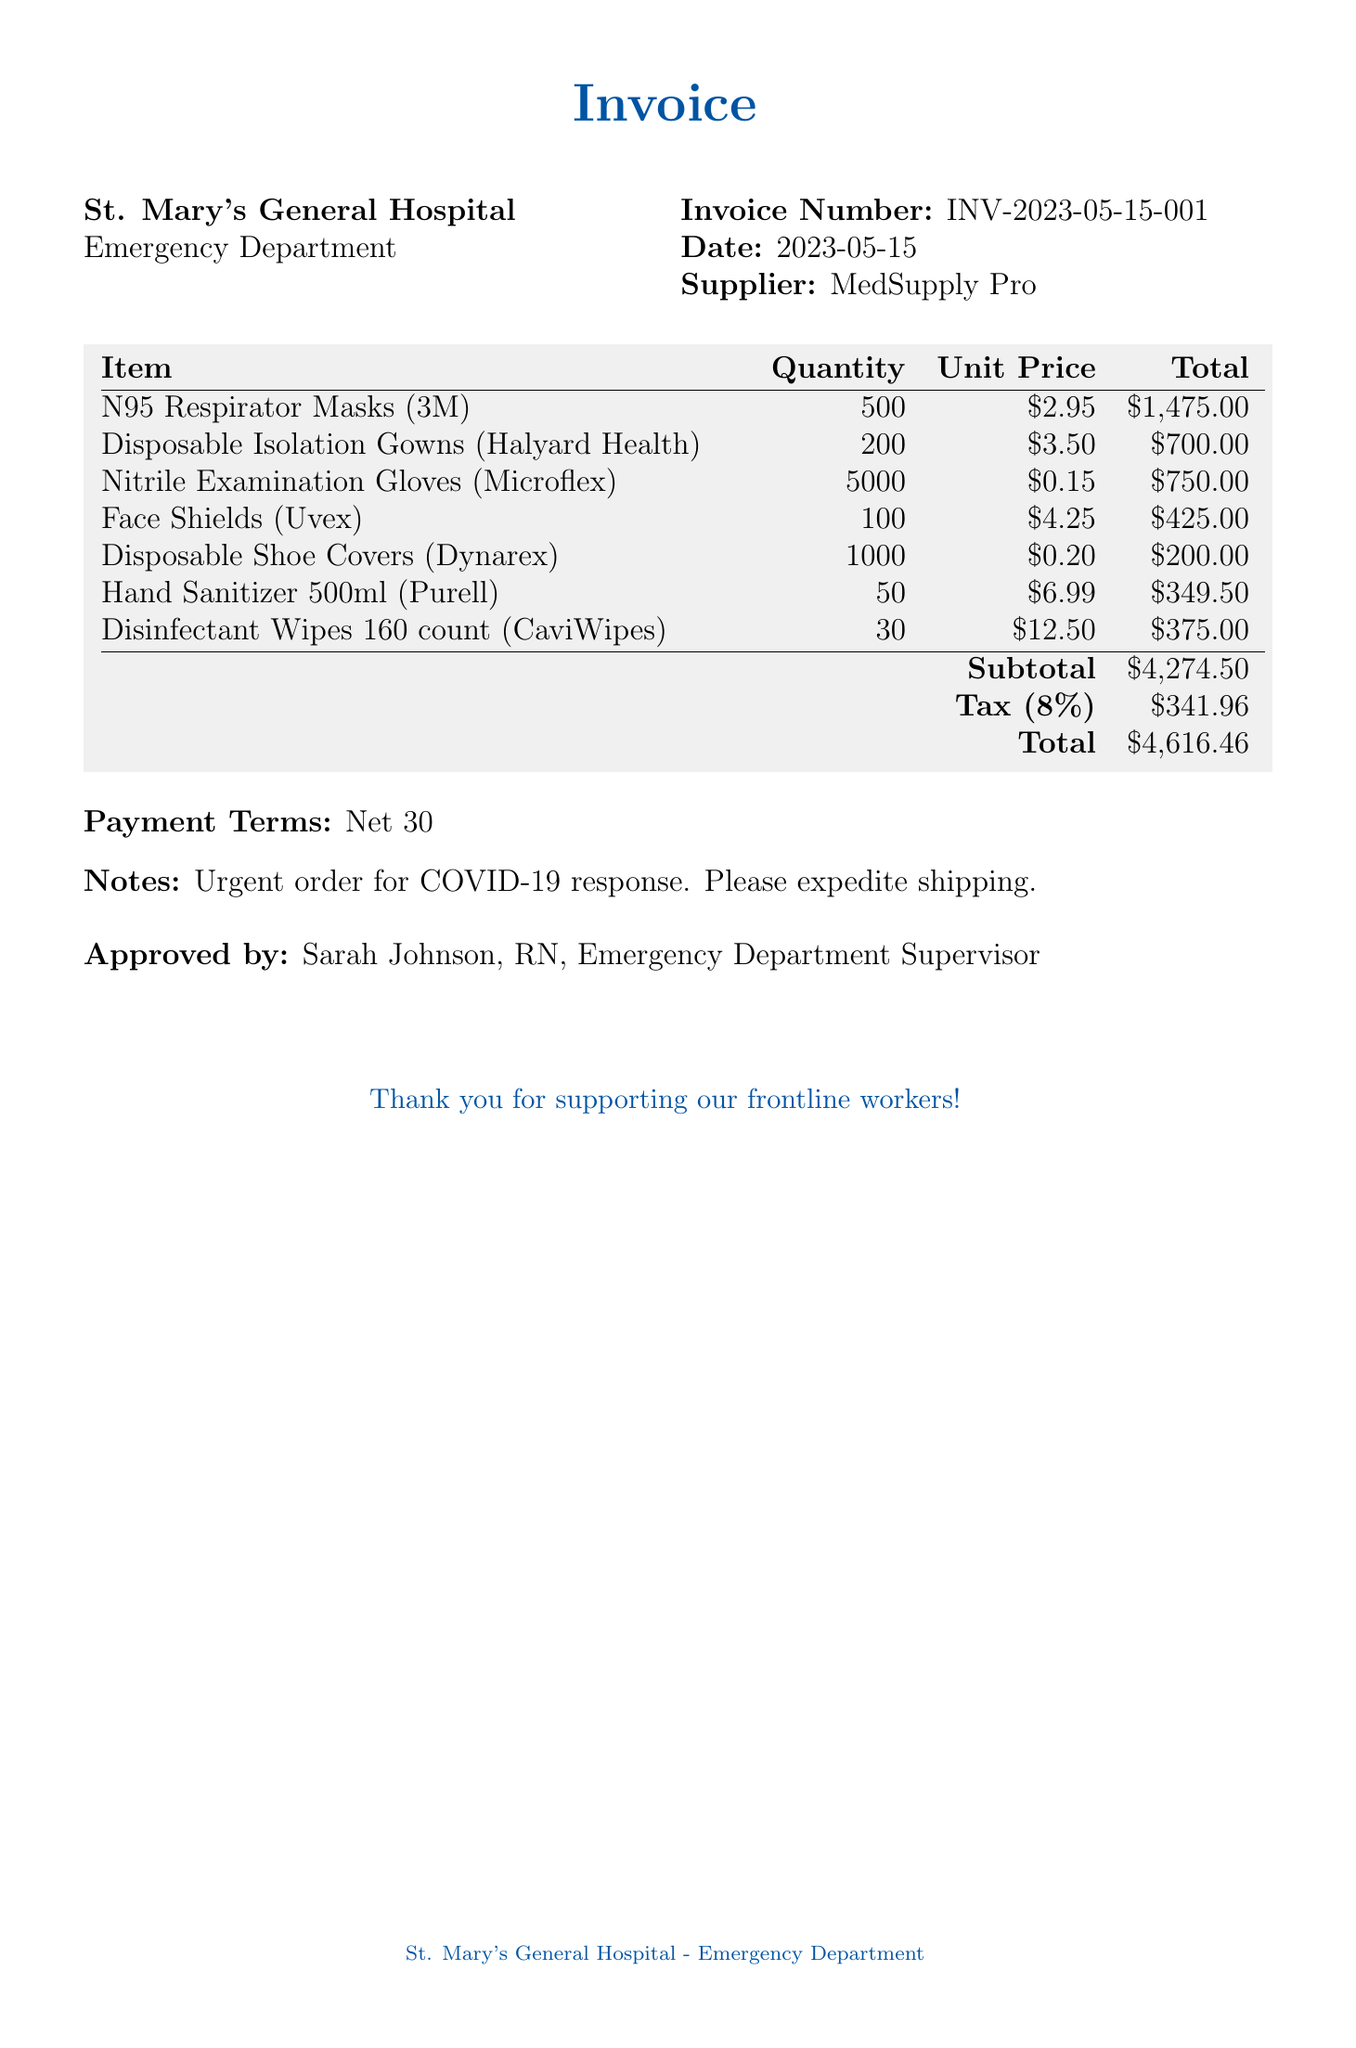What is the invoice number? The invoice number is specified in the document, which is INV-2023-05-15-001.
Answer: INV-2023-05-15-001 What is the date of the invoice? The date of the invoice is clearly mentioned, which is 2023-05-15.
Answer: 2023-05-15 How many N95 Respirator Masks were ordered? The quantity of N95 Respirator Masks listed in the document is 500.
Answer: 500 What is the total amount after tax? The total amount includes the subtotal and tax, which sums up to 4,616.46.
Answer: 4,616.46 What is the tax rate applied? The tax rate indicated in the document is 8 percent.
Answer: 8% Who approved the invoice? The invoice is approved by Sarah Johnson, who is identified as the RN and Emergency Department Supervisor.
Answer: Sarah Johnson, RN, Emergency Department Supervisor What item has the highest unit price? The unit price of Hand Sanitizer (500ml) is the highest, listed at 6.99.
Answer: 6.99 What is the subtotal before tax? The subtotal, which shows the total before tax additions, is stated as 4,274.50.
Answer: 4,274.50 What is the payment term noted? The payment term specified in the document is Net 30.
Answer: Net 30 